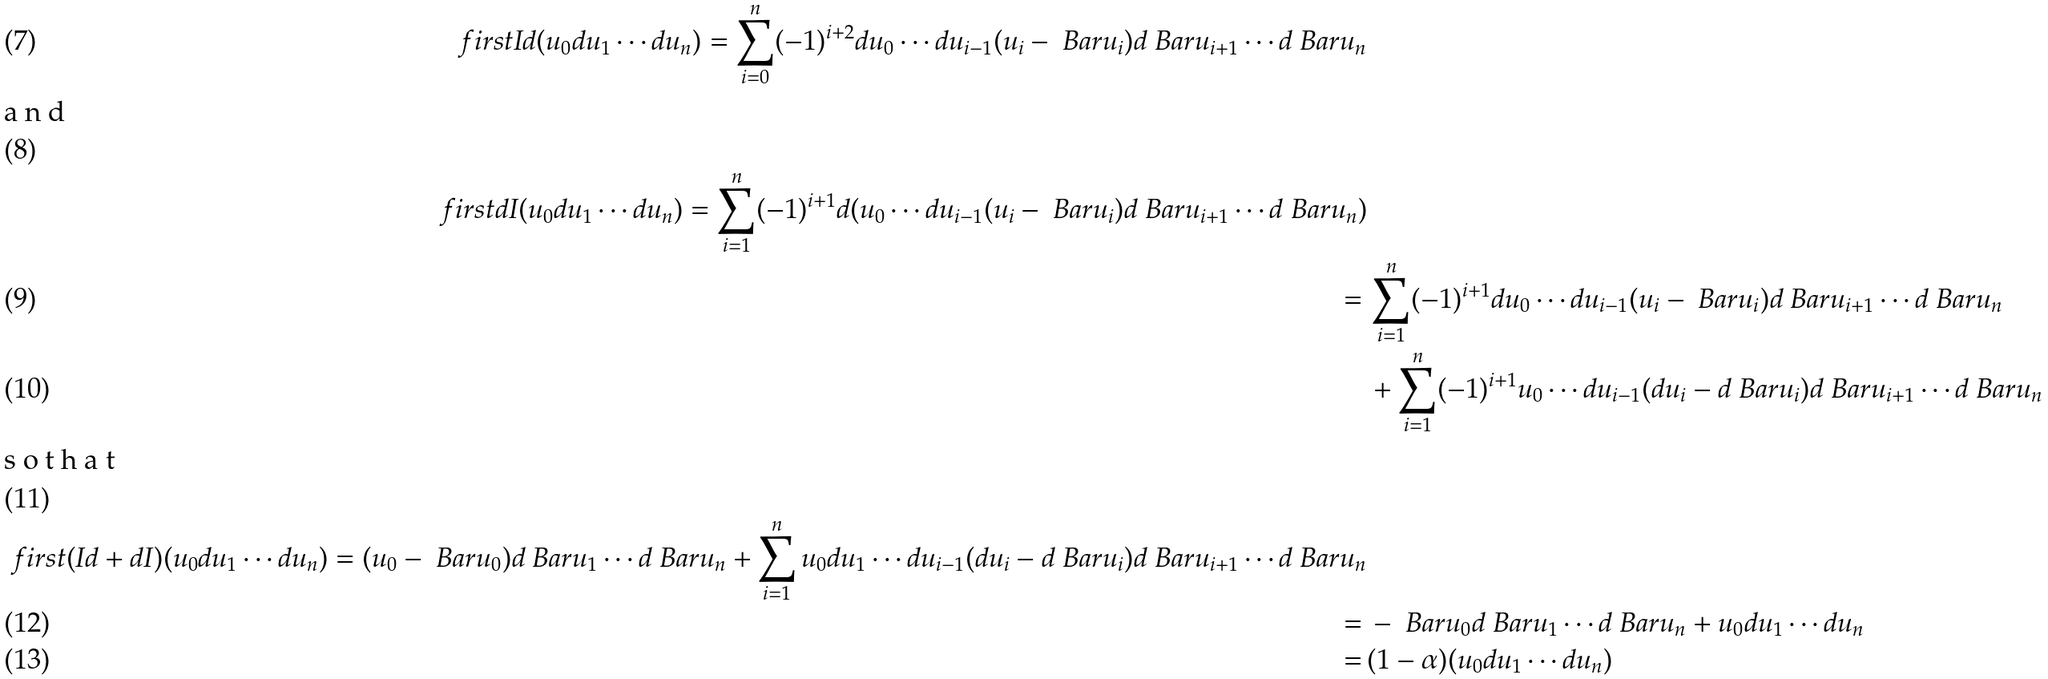Convert formula to latex. <formula><loc_0><loc_0><loc_500><loc_500>\ f i r s t I d ( u _ { 0 } d u _ { 1 } \cdots d u _ { n } ) = \sum _ { i = 0 } ^ { n } ( - 1 ) ^ { i + 2 } d u _ { 0 } \cdots d u _ { i - 1 } ( u _ { i } - \ B a r u _ { i } ) d \ B a r u _ { i + 1 } \cdots d \ B a r u _ { n } \\ \intertext { a n d } \ f i r s t d I ( u _ { 0 } d u _ { 1 } \cdots d u _ { n } ) = \sum _ { i = 1 } ^ { n } ( - 1 ) ^ { i + 1 } d ( u _ { 0 } \cdots d u _ { i - 1 } ( u _ { i } - \ B a r u _ { i } ) d \ B a r u _ { i + 1 } \cdots d \ B a r u _ { n } ) \\ = \, & \sum _ { i = 1 } ^ { n } ( - 1 ) ^ { i + 1 } d u _ { 0 } \cdots d u _ { i - 1 } ( u _ { i } - \ B a r u _ { i } ) d \ B a r u _ { i + 1 } \cdots d \ B a r u _ { n } \\ & + \sum _ { i = 1 } ^ { n } ( - 1 ) ^ { i + 1 } u _ { 0 } \cdots d u _ { i - 1 } ( d u _ { i } - d \ B a r u _ { i } ) d \ B a r u _ { i + 1 } \cdots d \ B a r u _ { n } \\ \intertext { s o t h a t } \ f i r s t ( I d + d I ) ( u _ { 0 } d u _ { 1 } \cdots d u _ { n } ) = ( u _ { 0 } - \ B a r u _ { 0 } ) d \ B a r u _ { 1 } \cdots d \ B a r u _ { n } + \sum _ { i = 1 } ^ { n } u _ { 0 } d u _ { 1 } \cdots d u _ { i - 1 } ( d u _ { i } - d \ B a r u _ { i } ) d \ B a r u _ { i + 1 } \cdots d \ B a r u _ { n } \\ = \, & - \ B a r u _ { 0 } d \ B a r u _ { 1 } \cdots d \ B a r u _ { n } + u _ { 0 } d u _ { 1 } \cdots d u _ { n } \\ = \, & ( 1 - \alpha ) ( u _ { 0 } d u _ { 1 } \cdots d u _ { n } )</formula> 